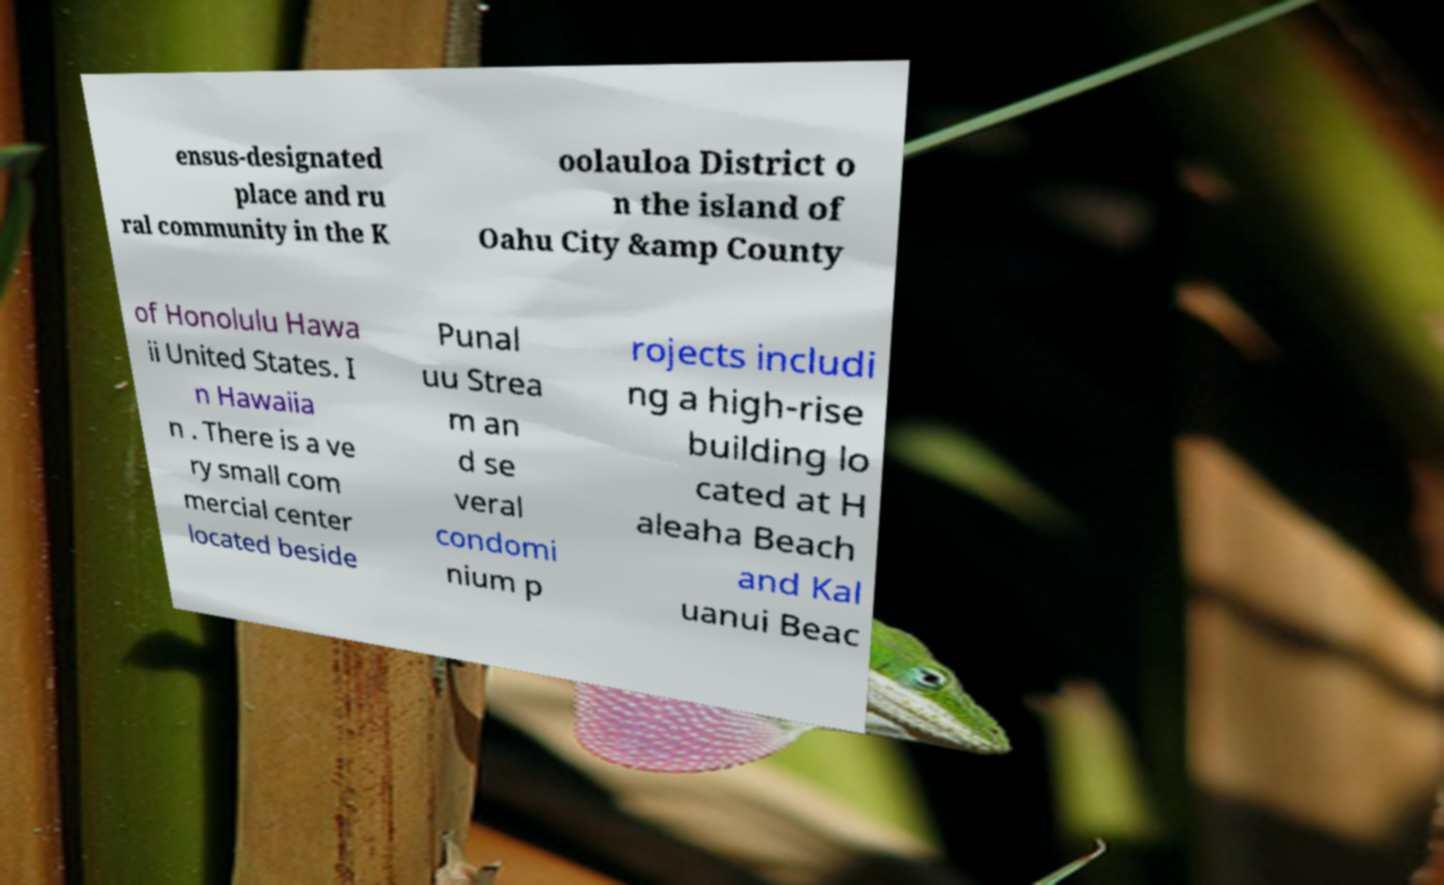For documentation purposes, I need the text within this image transcribed. Could you provide that? ensus-designated place and ru ral community in the K oolauloa District o n the island of Oahu City &amp County of Honolulu Hawa ii United States. I n Hawaiia n . There is a ve ry small com mercial center located beside Punal uu Strea m an d se veral condomi nium p rojects includi ng a high-rise building lo cated at H aleaha Beach and Kal uanui Beac 